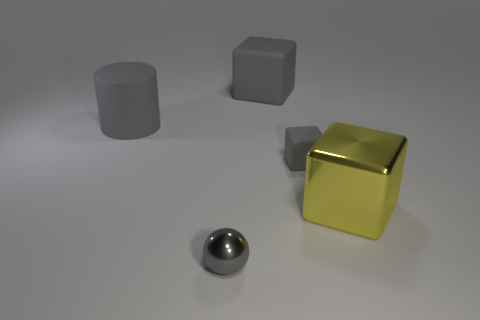Add 3 small gray blocks. How many objects exist? 8 Subtract all blocks. How many objects are left? 2 Subtract all tiny shiny balls. Subtract all metallic blocks. How many objects are left? 3 Add 4 big gray matte cylinders. How many big gray matte cylinders are left? 5 Add 1 green objects. How many green objects exist? 1 Subtract 0 brown balls. How many objects are left? 5 